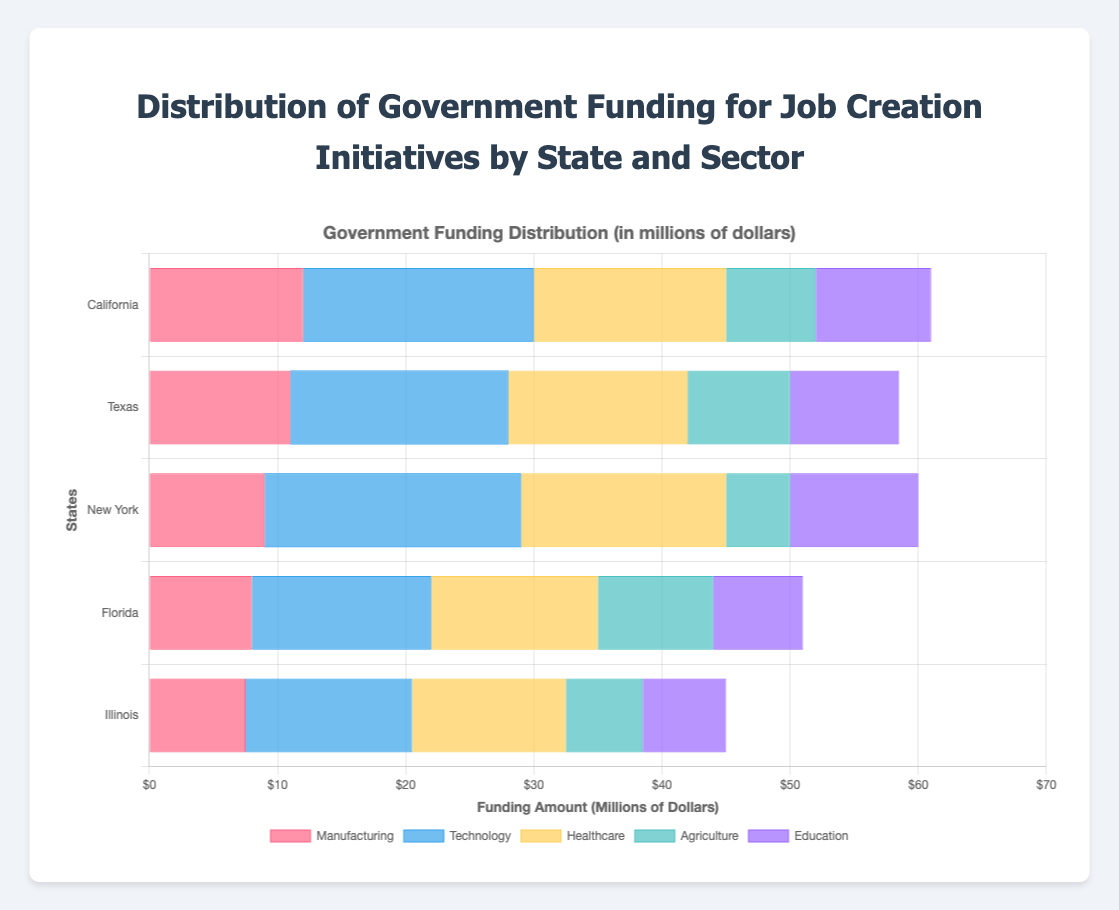What's the total government funding for the Technology sector across all states? Add up the funding for the Technology sector from each state: California: $18,000,000, Texas: $17,000,000, New York: $20,000,000, Florida: $14,000,000, Illinois: $13,000,000. The total is $18,000,000 + $17,000,000 + $20,000,000 + $14,000,000 + $13,000,000 = $82,000,000.
Answer: $82,000,000 Which state receives the highest government funding for Healthcare? Compare the funding amounts for the Healthcare sector from each state: California: $15,000,000, Texas: $14,000,000, New York: $16,000,000, Florida: $13,000,000, Illinois: $12,000,000. New York has the highest at $16,000,000.
Answer: New York What is the difference in government funding for Agriculture between California and Florida? Subtract the funding for Agriculture in Florida from that in California: California: $7,000,000, Florida: $9,000,000. The difference is $9,000,000 - $7,000,000 = $2,000,000.
Answer: $2,000,000 Which sector receives the least government funding in Texas? Compare the funding amounts for each sector in Texas: Manufacturing: $11,000,000, Technology: $17,000,000, Healthcare: $14,000,000, Agriculture: $8,000,000, Education: $8,500,000. Agriculture receives the least at $8,000,000.
Answer: Agriculture 